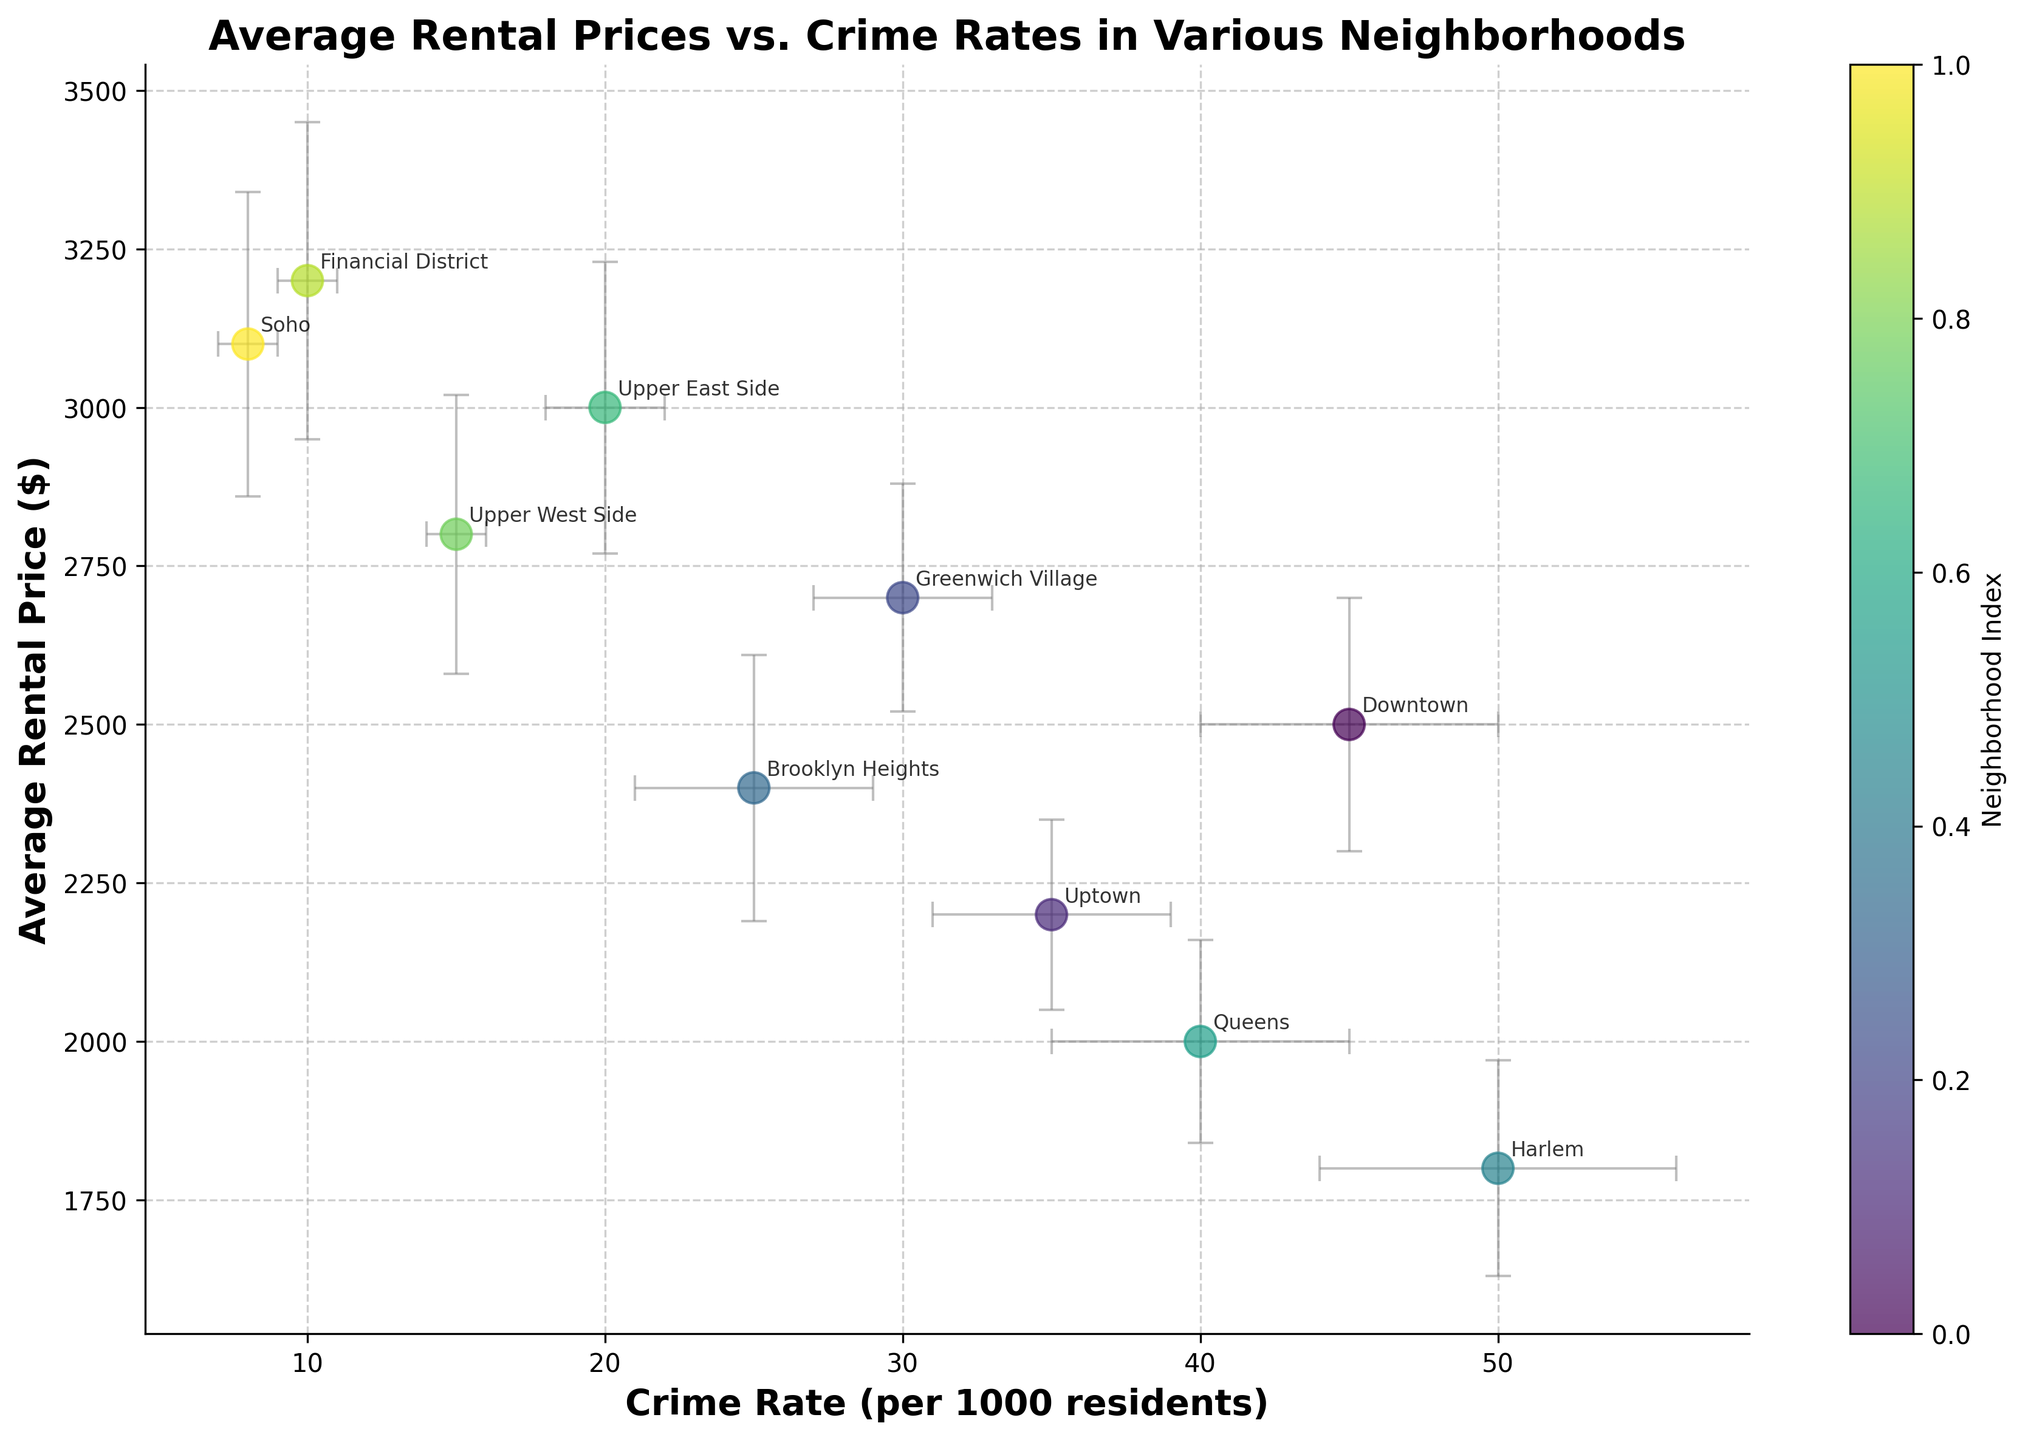What is the neighborhood with the highest average rental price? By looking at the y-axis, the neighborhood with the highest point on the chart represents the highest average rental price. Financial District has the highest point on the y-axis.
Answer: Financial District Which neighborhood has the lowest crime rate? By looking at the x-axis, the neighborhood with the leftmost point represents the lowest crime rate. Soho has the leftmost point on the x-axis.
Answer: Soho How does the average rental price in Downtown compare to that in Queens? Identify the points for Downtown and Queens on the plot. Downtown has an average rent of $2500 while Queens has $2000. Thus, Downtown has a higher average rental price.
Answer: Downtown has a higher average rental price Do neighborhoods with lower crime rates generally have higher rental prices? Observe the trend of the points on the plot. Points with lower crime rates on the x-axis generally appear higher on the y-axis, suggesting higher rental prices.
Answer: Yes What is the average rental price in Brooklyn Heights? Locate Brooklyn Heights and read its y-coordinate value. The point for Brooklyn Heights is at $2400 on the y-axis.
Answer: $2400 Which neighborhood has the highest standard error in rental price, and what is its value? Identify the neighborhood with the largest error bars for rental price. The Financial District has the largest vertical error bars with a value of $250.
Answer: Financial District, $250 What's the difference in crime rates between Harlem and Upper East Side? Find the x-coordinates for Harlem and Upper East Side. Harlem is at 50 and Upper East Side is at 20. Subtract the smaller value from the larger one: 50 - 20.
Answer: 30 Which neighborhood has the smallest error bar for crime rate, and what is its value? Identify the neighborhood with the smallest horizontal error bars. Upper West Side has the smallest, with a value of 1.
Answer: Upper West Side, 1 Is there a noticeable trend between crime rates and rental prices when comparing Greenwich Village and Brooklyn Heights? Greenwich Village has a higher rental price and a higher crime rate than Brooklyn Heights. This suggests that within this limited comparison, there's no clear trend as they are inversely related.
Answer: No clear trend How does the average rental price in Soho compare to the average rental price in Uptown? Locate the points for Soho and Uptown. Soho's average rental price is $3100, whereas Uptown's is $2200. Therefore, Soho has a higher rental price.
Answer: Soho has a higher rental price 